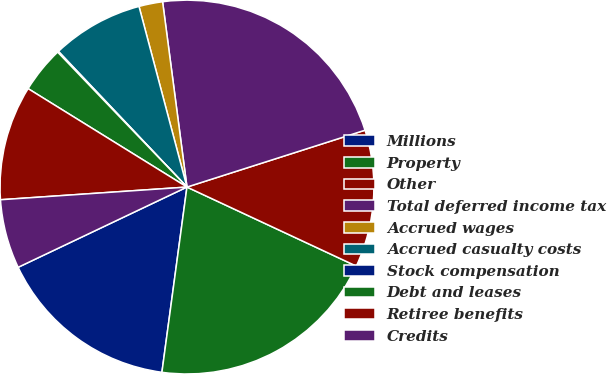Convert chart. <chart><loc_0><loc_0><loc_500><loc_500><pie_chart><fcel>Millions<fcel>Property<fcel>Other<fcel>Total deferred income tax<fcel>Accrued wages<fcel>Accrued casualty costs<fcel>Stock compensation<fcel>Debt and leases<fcel>Retiree benefits<fcel>Credits<nl><fcel>15.8%<fcel>20.19%<fcel>11.87%<fcel>22.16%<fcel>2.05%<fcel>7.94%<fcel>0.09%<fcel>4.01%<fcel>9.91%<fcel>5.98%<nl></chart> 